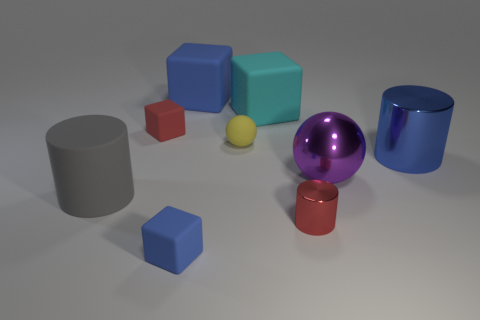Add 1 big yellow things. How many objects exist? 10 Subtract all cylinders. How many objects are left? 6 Subtract 1 blue cylinders. How many objects are left? 8 Subtract all small red metal cubes. Subtract all red rubber objects. How many objects are left? 8 Add 7 big blue matte blocks. How many big blue matte blocks are left? 8 Add 9 red rubber balls. How many red rubber balls exist? 9 